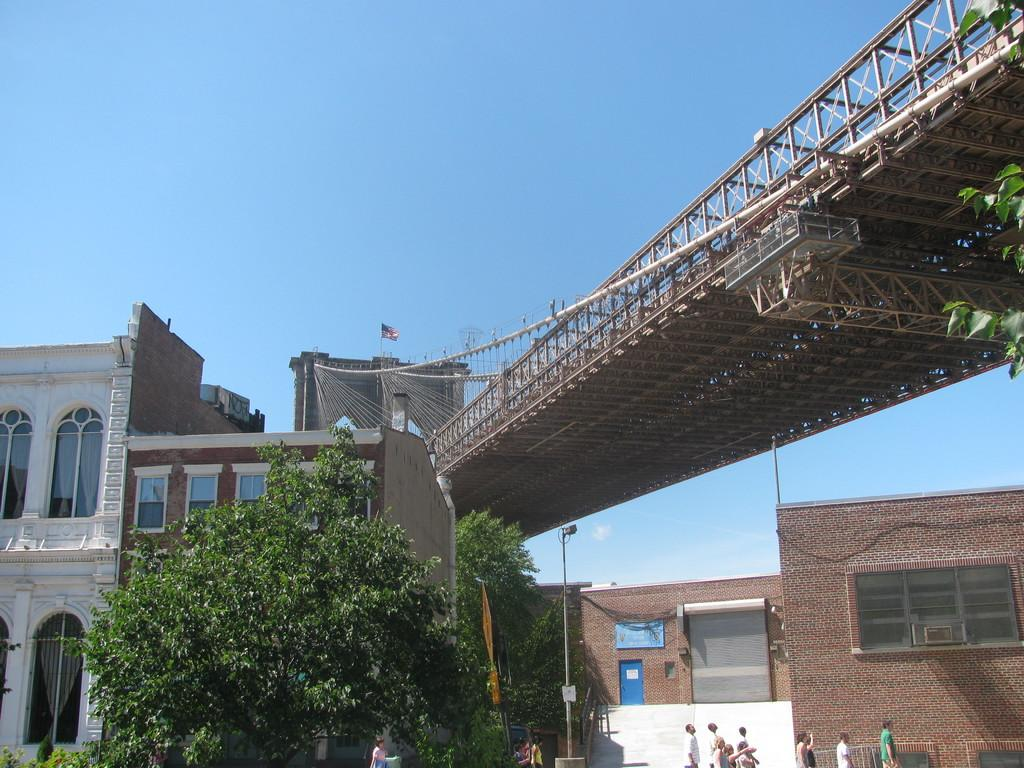What is located in the foreground of the picture? There are trees, a streetlight, plants, and people in the foreground of the picture. What can be seen in the center of the picture? There is a bridge and buildings in the center of the picture. What is visible at the top of the picture? The sky is visible at the top of the picture. Where is the kitten using the toothpaste in the image? There is no kitten or toothpaste present in the image. What scientific discovery is being made in the image? There is no scientific discovery being made in the image; it features a scene with trees, a streetlight, plants, people, a bridge, buildings, and the sky. 